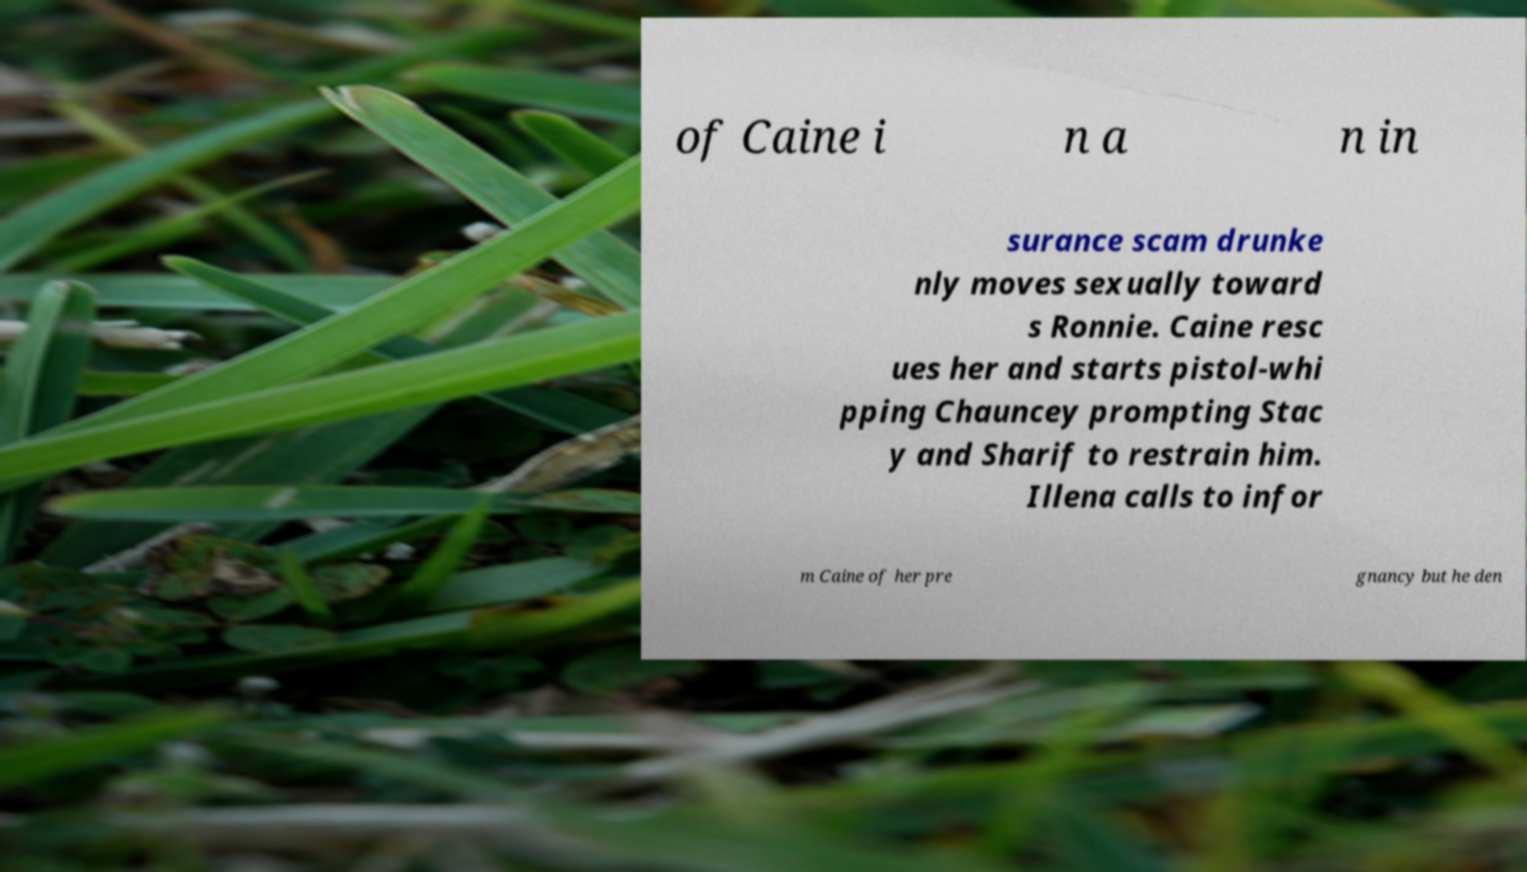For documentation purposes, I need the text within this image transcribed. Could you provide that? of Caine i n a n in surance scam drunke nly moves sexually toward s Ronnie. Caine resc ues her and starts pistol-whi pping Chauncey prompting Stac y and Sharif to restrain him. Illena calls to infor m Caine of her pre gnancy but he den 